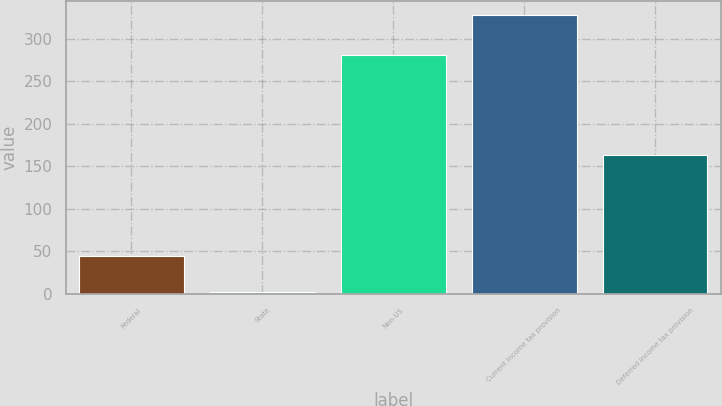Convert chart to OTSL. <chart><loc_0><loc_0><loc_500><loc_500><bar_chart><fcel>Federal<fcel>State<fcel>Non-US<fcel>Current income tax provision<fcel>Deferred income tax provision<nl><fcel>45<fcel>2<fcel>281<fcel>328<fcel>163<nl></chart> 